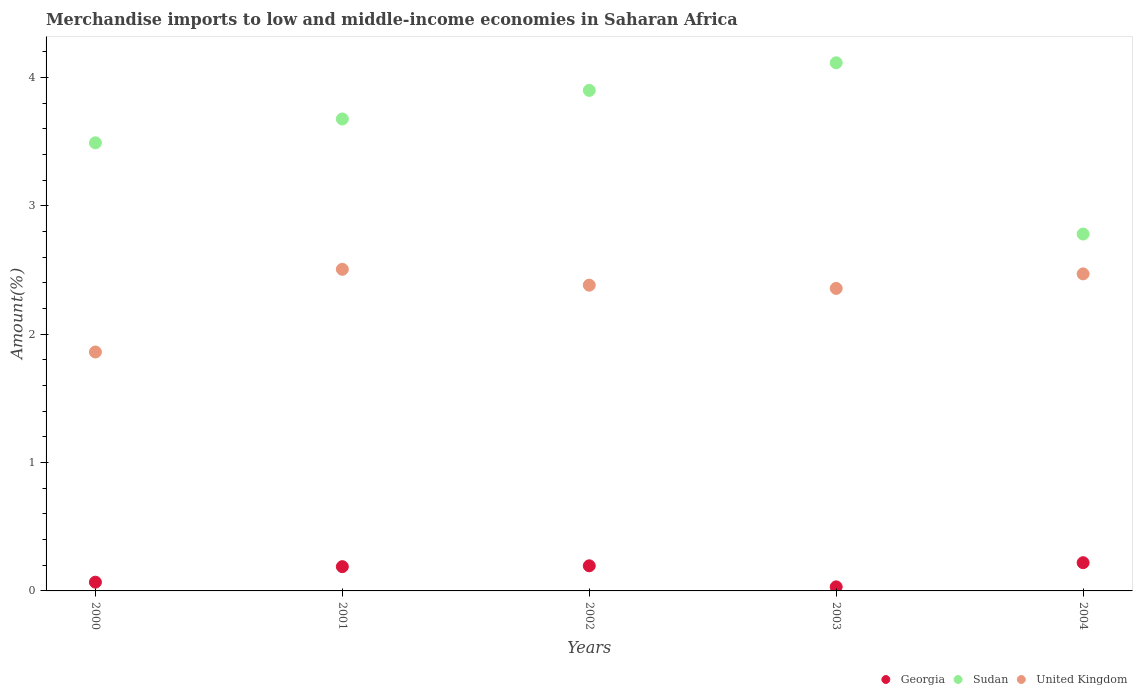What is the percentage of amount earned from merchandise imports in Georgia in 2004?
Your answer should be very brief. 0.22. Across all years, what is the maximum percentage of amount earned from merchandise imports in United Kingdom?
Ensure brevity in your answer.  2.51. Across all years, what is the minimum percentage of amount earned from merchandise imports in United Kingdom?
Offer a terse response. 1.86. What is the total percentage of amount earned from merchandise imports in Georgia in the graph?
Offer a very short reply. 0.7. What is the difference between the percentage of amount earned from merchandise imports in Georgia in 2001 and that in 2002?
Make the answer very short. -0.01. What is the difference between the percentage of amount earned from merchandise imports in Georgia in 2002 and the percentage of amount earned from merchandise imports in Sudan in 2000?
Your response must be concise. -3.29. What is the average percentage of amount earned from merchandise imports in United Kingdom per year?
Make the answer very short. 2.31. In the year 2002, what is the difference between the percentage of amount earned from merchandise imports in Georgia and percentage of amount earned from merchandise imports in Sudan?
Provide a succinct answer. -3.7. In how many years, is the percentage of amount earned from merchandise imports in Georgia greater than 0.6000000000000001 %?
Your response must be concise. 0. What is the ratio of the percentage of amount earned from merchandise imports in Sudan in 2002 to that in 2004?
Offer a terse response. 1.4. Is the percentage of amount earned from merchandise imports in Sudan in 2003 less than that in 2004?
Make the answer very short. No. What is the difference between the highest and the second highest percentage of amount earned from merchandise imports in United Kingdom?
Offer a terse response. 0.04. What is the difference between the highest and the lowest percentage of amount earned from merchandise imports in United Kingdom?
Keep it short and to the point. 0.64. Is it the case that in every year, the sum of the percentage of amount earned from merchandise imports in United Kingdom and percentage of amount earned from merchandise imports in Sudan  is greater than the percentage of amount earned from merchandise imports in Georgia?
Provide a short and direct response. Yes. Is the percentage of amount earned from merchandise imports in Sudan strictly less than the percentage of amount earned from merchandise imports in Georgia over the years?
Ensure brevity in your answer.  No. Does the graph contain any zero values?
Provide a succinct answer. No. How many legend labels are there?
Offer a very short reply. 3. How are the legend labels stacked?
Your answer should be very brief. Horizontal. What is the title of the graph?
Your answer should be compact. Merchandise imports to low and middle-income economies in Saharan Africa. Does "Europe(developing only)" appear as one of the legend labels in the graph?
Provide a succinct answer. No. What is the label or title of the X-axis?
Keep it short and to the point. Years. What is the label or title of the Y-axis?
Your answer should be very brief. Amount(%). What is the Amount(%) in Georgia in 2000?
Provide a short and direct response. 0.07. What is the Amount(%) of Sudan in 2000?
Ensure brevity in your answer.  3.49. What is the Amount(%) in United Kingdom in 2000?
Provide a succinct answer. 1.86. What is the Amount(%) of Georgia in 2001?
Provide a succinct answer. 0.19. What is the Amount(%) of Sudan in 2001?
Keep it short and to the point. 3.68. What is the Amount(%) in United Kingdom in 2001?
Your response must be concise. 2.51. What is the Amount(%) in Georgia in 2002?
Provide a short and direct response. 0.2. What is the Amount(%) in Sudan in 2002?
Give a very brief answer. 3.9. What is the Amount(%) in United Kingdom in 2002?
Provide a short and direct response. 2.38. What is the Amount(%) of Georgia in 2003?
Your answer should be compact. 0.03. What is the Amount(%) in Sudan in 2003?
Your answer should be compact. 4.11. What is the Amount(%) in United Kingdom in 2003?
Ensure brevity in your answer.  2.36. What is the Amount(%) in Georgia in 2004?
Your answer should be compact. 0.22. What is the Amount(%) of Sudan in 2004?
Your answer should be very brief. 2.78. What is the Amount(%) in United Kingdom in 2004?
Ensure brevity in your answer.  2.47. Across all years, what is the maximum Amount(%) in Georgia?
Your answer should be compact. 0.22. Across all years, what is the maximum Amount(%) in Sudan?
Provide a short and direct response. 4.11. Across all years, what is the maximum Amount(%) of United Kingdom?
Your answer should be very brief. 2.51. Across all years, what is the minimum Amount(%) in Georgia?
Your answer should be very brief. 0.03. Across all years, what is the minimum Amount(%) of Sudan?
Offer a terse response. 2.78. Across all years, what is the minimum Amount(%) in United Kingdom?
Provide a short and direct response. 1.86. What is the total Amount(%) in Georgia in the graph?
Keep it short and to the point. 0.7. What is the total Amount(%) of Sudan in the graph?
Your answer should be compact. 17.96. What is the total Amount(%) in United Kingdom in the graph?
Provide a short and direct response. 11.57. What is the difference between the Amount(%) in Georgia in 2000 and that in 2001?
Make the answer very short. -0.12. What is the difference between the Amount(%) in Sudan in 2000 and that in 2001?
Offer a terse response. -0.19. What is the difference between the Amount(%) of United Kingdom in 2000 and that in 2001?
Provide a succinct answer. -0.64. What is the difference between the Amount(%) in Georgia in 2000 and that in 2002?
Give a very brief answer. -0.13. What is the difference between the Amount(%) in Sudan in 2000 and that in 2002?
Keep it short and to the point. -0.41. What is the difference between the Amount(%) in United Kingdom in 2000 and that in 2002?
Give a very brief answer. -0.52. What is the difference between the Amount(%) of Georgia in 2000 and that in 2003?
Offer a very short reply. 0.04. What is the difference between the Amount(%) of Sudan in 2000 and that in 2003?
Offer a very short reply. -0.62. What is the difference between the Amount(%) in United Kingdom in 2000 and that in 2003?
Ensure brevity in your answer.  -0.5. What is the difference between the Amount(%) in Georgia in 2000 and that in 2004?
Make the answer very short. -0.15. What is the difference between the Amount(%) of Sudan in 2000 and that in 2004?
Offer a terse response. 0.71. What is the difference between the Amount(%) of United Kingdom in 2000 and that in 2004?
Your answer should be very brief. -0.61. What is the difference between the Amount(%) in Georgia in 2001 and that in 2002?
Make the answer very short. -0.01. What is the difference between the Amount(%) in Sudan in 2001 and that in 2002?
Provide a short and direct response. -0.22. What is the difference between the Amount(%) of United Kingdom in 2001 and that in 2002?
Make the answer very short. 0.12. What is the difference between the Amount(%) of Georgia in 2001 and that in 2003?
Ensure brevity in your answer.  0.16. What is the difference between the Amount(%) in Sudan in 2001 and that in 2003?
Provide a short and direct response. -0.44. What is the difference between the Amount(%) of United Kingdom in 2001 and that in 2003?
Your answer should be very brief. 0.15. What is the difference between the Amount(%) of Georgia in 2001 and that in 2004?
Your response must be concise. -0.03. What is the difference between the Amount(%) in Sudan in 2001 and that in 2004?
Ensure brevity in your answer.  0.9. What is the difference between the Amount(%) of United Kingdom in 2001 and that in 2004?
Keep it short and to the point. 0.04. What is the difference between the Amount(%) in Georgia in 2002 and that in 2003?
Provide a short and direct response. 0.16. What is the difference between the Amount(%) in Sudan in 2002 and that in 2003?
Your answer should be very brief. -0.22. What is the difference between the Amount(%) in United Kingdom in 2002 and that in 2003?
Offer a very short reply. 0.03. What is the difference between the Amount(%) of Georgia in 2002 and that in 2004?
Keep it short and to the point. -0.02. What is the difference between the Amount(%) of Sudan in 2002 and that in 2004?
Offer a terse response. 1.12. What is the difference between the Amount(%) in United Kingdom in 2002 and that in 2004?
Ensure brevity in your answer.  -0.09. What is the difference between the Amount(%) in Georgia in 2003 and that in 2004?
Offer a terse response. -0.19. What is the difference between the Amount(%) of Sudan in 2003 and that in 2004?
Offer a very short reply. 1.33. What is the difference between the Amount(%) in United Kingdom in 2003 and that in 2004?
Offer a terse response. -0.11. What is the difference between the Amount(%) in Georgia in 2000 and the Amount(%) in Sudan in 2001?
Give a very brief answer. -3.61. What is the difference between the Amount(%) in Georgia in 2000 and the Amount(%) in United Kingdom in 2001?
Give a very brief answer. -2.44. What is the difference between the Amount(%) in Sudan in 2000 and the Amount(%) in United Kingdom in 2001?
Keep it short and to the point. 0.99. What is the difference between the Amount(%) of Georgia in 2000 and the Amount(%) of Sudan in 2002?
Make the answer very short. -3.83. What is the difference between the Amount(%) in Georgia in 2000 and the Amount(%) in United Kingdom in 2002?
Offer a very short reply. -2.31. What is the difference between the Amount(%) in Sudan in 2000 and the Amount(%) in United Kingdom in 2002?
Your answer should be compact. 1.11. What is the difference between the Amount(%) in Georgia in 2000 and the Amount(%) in Sudan in 2003?
Provide a succinct answer. -4.05. What is the difference between the Amount(%) of Georgia in 2000 and the Amount(%) of United Kingdom in 2003?
Make the answer very short. -2.29. What is the difference between the Amount(%) in Sudan in 2000 and the Amount(%) in United Kingdom in 2003?
Offer a terse response. 1.13. What is the difference between the Amount(%) of Georgia in 2000 and the Amount(%) of Sudan in 2004?
Give a very brief answer. -2.71. What is the difference between the Amount(%) of Georgia in 2000 and the Amount(%) of United Kingdom in 2004?
Offer a terse response. -2.4. What is the difference between the Amount(%) of Sudan in 2000 and the Amount(%) of United Kingdom in 2004?
Your answer should be compact. 1.02. What is the difference between the Amount(%) in Georgia in 2001 and the Amount(%) in Sudan in 2002?
Provide a succinct answer. -3.71. What is the difference between the Amount(%) in Georgia in 2001 and the Amount(%) in United Kingdom in 2002?
Make the answer very short. -2.19. What is the difference between the Amount(%) in Sudan in 2001 and the Amount(%) in United Kingdom in 2002?
Give a very brief answer. 1.29. What is the difference between the Amount(%) of Georgia in 2001 and the Amount(%) of Sudan in 2003?
Your answer should be very brief. -3.92. What is the difference between the Amount(%) in Georgia in 2001 and the Amount(%) in United Kingdom in 2003?
Your answer should be compact. -2.17. What is the difference between the Amount(%) in Sudan in 2001 and the Amount(%) in United Kingdom in 2003?
Offer a very short reply. 1.32. What is the difference between the Amount(%) of Georgia in 2001 and the Amount(%) of Sudan in 2004?
Provide a short and direct response. -2.59. What is the difference between the Amount(%) in Georgia in 2001 and the Amount(%) in United Kingdom in 2004?
Offer a very short reply. -2.28. What is the difference between the Amount(%) of Sudan in 2001 and the Amount(%) of United Kingdom in 2004?
Your answer should be very brief. 1.21. What is the difference between the Amount(%) of Georgia in 2002 and the Amount(%) of Sudan in 2003?
Offer a very short reply. -3.92. What is the difference between the Amount(%) in Georgia in 2002 and the Amount(%) in United Kingdom in 2003?
Offer a very short reply. -2.16. What is the difference between the Amount(%) in Sudan in 2002 and the Amount(%) in United Kingdom in 2003?
Offer a terse response. 1.54. What is the difference between the Amount(%) in Georgia in 2002 and the Amount(%) in Sudan in 2004?
Your answer should be very brief. -2.58. What is the difference between the Amount(%) in Georgia in 2002 and the Amount(%) in United Kingdom in 2004?
Offer a very short reply. -2.27. What is the difference between the Amount(%) of Sudan in 2002 and the Amount(%) of United Kingdom in 2004?
Ensure brevity in your answer.  1.43. What is the difference between the Amount(%) in Georgia in 2003 and the Amount(%) in Sudan in 2004?
Keep it short and to the point. -2.75. What is the difference between the Amount(%) of Georgia in 2003 and the Amount(%) of United Kingdom in 2004?
Your answer should be very brief. -2.44. What is the difference between the Amount(%) in Sudan in 2003 and the Amount(%) in United Kingdom in 2004?
Provide a succinct answer. 1.64. What is the average Amount(%) in Georgia per year?
Provide a succinct answer. 0.14. What is the average Amount(%) in Sudan per year?
Offer a terse response. 3.59. What is the average Amount(%) in United Kingdom per year?
Give a very brief answer. 2.31. In the year 2000, what is the difference between the Amount(%) in Georgia and Amount(%) in Sudan?
Offer a terse response. -3.42. In the year 2000, what is the difference between the Amount(%) of Georgia and Amount(%) of United Kingdom?
Your response must be concise. -1.79. In the year 2000, what is the difference between the Amount(%) of Sudan and Amount(%) of United Kingdom?
Offer a terse response. 1.63. In the year 2001, what is the difference between the Amount(%) in Georgia and Amount(%) in Sudan?
Provide a succinct answer. -3.49. In the year 2001, what is the difference between the Amount(%) of Georgia and Amount(%) of United Kingdom?
Make the answer very short. -2.32. In the year 2001, what is the difference between the Amount(%) of Sudan and Amount(%) of United Kingdom?
Your answer should be very brief. 1.17. In the year 2002, what is the difference between the Amount(%) of Georgia and Amount(%) of Sudan?
Provide a succinct answer. -3.7. In the year 2002, what is the difference between the Amount(%) of Georgia and Amount(%) of United Kingdom?
Offer a very short reply. -2.19. In the year 2002, what is the difference between the Amount(%) in Sudan and Amount(%) in United Kingdom?
Give a very brief answer. 1.52. In the year 2003, what is the difference between the Amount(%) in Georgia and Amount(%) in Sudan?
Provide a succinct answer. -4.08. In the year 2003, what is the difference between the Amount(%) in Georgia and Amount(%) in United Kingdom?
Your response must be concise. -2.32. In the year 2003, what is the difference between the Amount(%) of Sudan and Amount(%) of United Kingdom?
Offer a terse response. 1.76. In the year 2004, what is the difference between the Amount(%) in Georgia and Amount(%) in Sudan?
Make the answer very short. -2.56. In the year 2004, what is the difference between the Amount(%) in Georgia and Amount(%) in United Kingdom?
Your answer should be compact. -2.25. In the year 2004, what is the difference between the Amount(%) in Sudan and Amount(%) in United Kingdom?
Make the answer very short. 0.31. What is the ratio of the Amount(%) of Georgia in 2000 to that in 2001?
Keep it short and to the point. 0.36. What is the ratio of the Amount(%) of Sudan in 2000 to that in 2001?
Your answer should be compact. 0.95. What is the ratio of the Amount(%) in United Kingdom in 2000 to that in 2001?
Ensure brevity in your answer.  0.74. What is the ratio of the Amount(%) of Georgia in 2000 to that in 2002?
Provide a short and direct response. 0.35. What is the ratio of the Amount(%) in Sudan in 2000 to that in 2002?
Make the answer very short. 0.9. What is the ratio of the Amount(%) of United Kingdom in 2000 to that in 2002?
Ensure brevity in your answer.  0.78. What is the ratio of the Amount(%) of Georgia in 2000 to that in 2003?
Your answer should be very brief. 2.15. What is the ratio of the Amount(%) of Sudan in 2000 to that in 2003?
Make the answer very short. 0.85. What is the ratio of the Amount(%) of United Kingdom in 2000 to that in 2003?
Ensure brevity in your answer.  0.79. What is the ratio of the Amount(%) in Georgia in 2000 to that in 2004?
Your answer should be compact. 0.31. What is the ratio of the Amount(%) in Sudan in 2000 to that in 2004?
Offer a very short reply. 1.26. What is the ratio of the Amount(%) of United Kingdom in 2000 to that in 2004?
Make the answer very short. 0.75. What is the ratio of the Amount(%) in Georgia in 2001 to that in 2002?
Offer a terse response. 0.97. What is the ratio of the Amount(%) in Sudan in 2001 to that in 2002?
Keep it short and to the point. 0.94. What is the ratio of the Amount(%) in United Kingdom in 2001 to that in 2002?
Ensure brevity in your answer.  1.05. What is the ratio of the Amount(%) in Georgia in 2001 to that in 2003?
Offer a terse response. 5.97. What is the ratio of the Amount(%) in Sudan in 2001 to that in 2003?
Offer a terse response. 0.89. What is the ratio of the Amount(%) in United Kingdom in 2001 to that in 2003?
Your response must be concise. 1.06. What is the ratio of the Amount(%) in Georgia in 2001 to that in 2004?
Provide a succinct answer. 0.86. What is the ratio of the Amount(%) of Sudan in 2001 to that in 2004?
Provide a short and direct response. 1.32. What is the ratio of the Amount(%) of United Kingdom in 2001 to that in 2004?
Make the answer very short. 1.01. What is the ratio of the Amount(%) of Georgia in 2002 to that in 2003?
Provide a short and direct response. 6.18. What is the ratio of the Amount(%) of Sudan in 2002 to that in 2003?
Give a very brief answer. 0.95. What is the ratio of the Amount(%) of United Kingdom in 2002 to that in 2003?
Provide a succinct answer. 1.01. What is the ratio of the Amount(%) in Georgia in 2002 to that in 2004?
Provide a succinct answer. 0.89. What is the ratio of the Amount(%) in Sudan in 2002 to that in 2004?
Give a very brief answer. 1.4. What is the ratio of the Amount(%) of United Kingdom in 2002 to that in 2004?
Provide a short and direct response. 0.96. What is the ratio of the Amount(%) in Georgia in 2003 to that in 2004?
Provide a short and direct response. 0.14. What is the ratio of the Amount(%) in Sudan in 2003 to that in 2004?
Your response must be concise. 1.48. What is the ratio of the Amount(%) in United Kingdom in 2003 to that in 2004?
Offer a very short reply. 0.95. What is the difference between the highest and the second highest Amount(%) of Georgia?
Ensure brevity in your answer.  0.02. What is the difference between the highest and the second highest Amount(%) in Sudan?
Keep it short and to the point. 0.22. What is the difference between the highest and the second highest Amount(%) of United Kingdom?
Make the answer very short. 0.04. What is the difference between the highest and the lowest Amount(%) in Georgia?
Give a very brief answer. 0.19. What is the difference between the highest and the lowest Amount(%) in Sudan?
Provide a succinct answer. 1.33. What is the difference between the highest and the lowest Amount(%) of United Kingdom?
Provide a succinct answer. 0.64. 